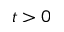Convert formula to latex. <formula><loc_0><loc_0><loc_500><loc_500>t > 0</formula> 